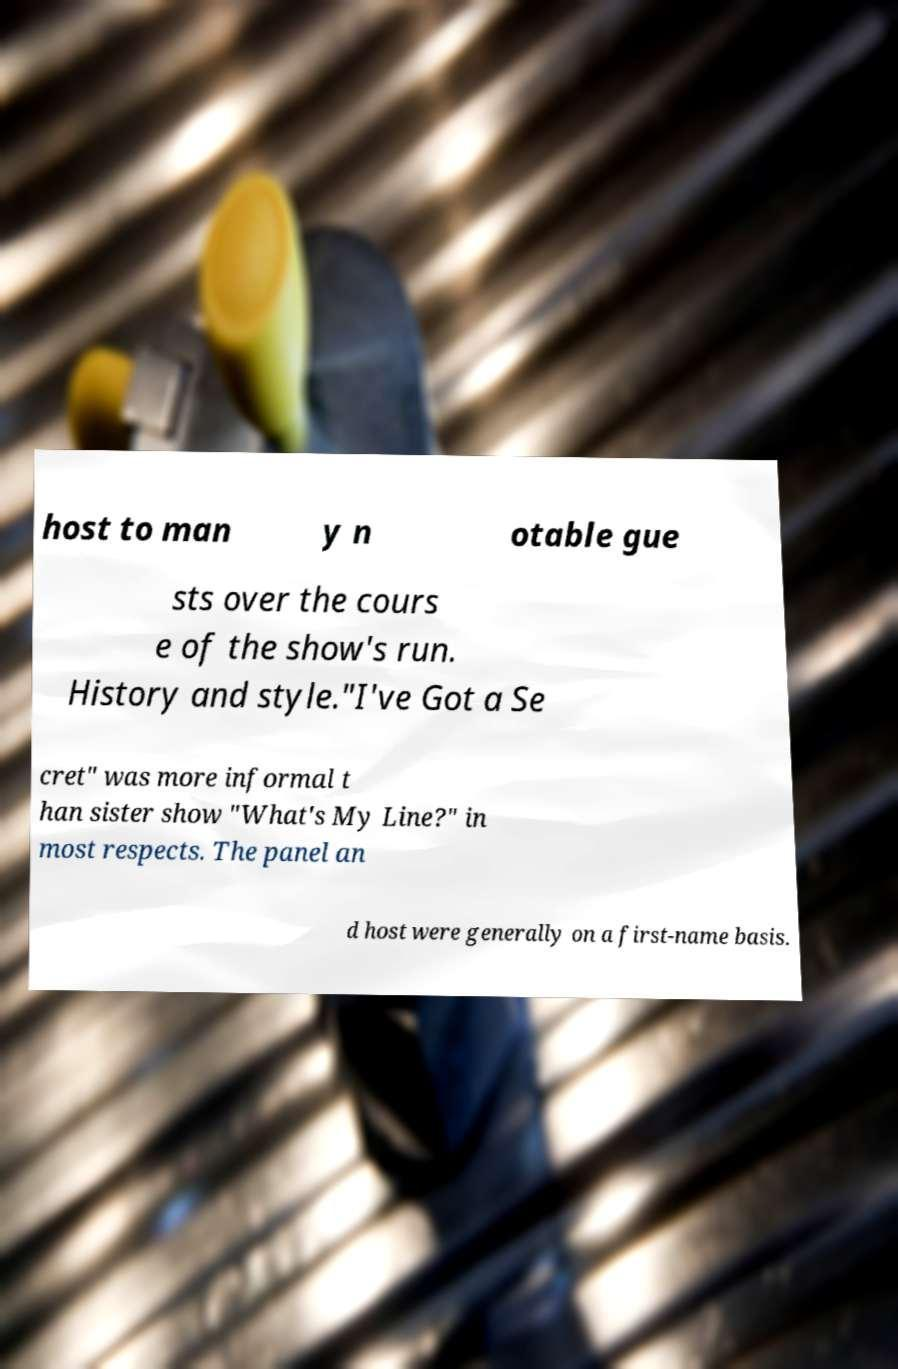Could you extract and type out the text from this image? host to man y n otable gue sts over the cours e of the show's run. History and style."I've Got a Se cret" was more informal t han sister show "What's My Line?" in most respects. The panel an d host were generally on a first-name basis. 